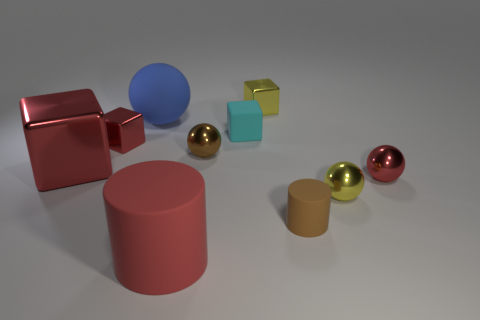Subtract all tiny yellow spheres. How many spheres are left? 3 Subtract all gray cubes. Subtract all gray spheres. How many cubes are left? 4 Subtract all cylinders. How many objects are left? 8 Add 9 large red rubber objects. How many large red rubber objects are left? 10 Add 2 small metallic cubes. How many small metallic cubes exist? 4 Subtract 0 brown cubes. How many objects are left? 10 Subtract all big red metal objects. Subtract all yellow balls. How many objects are left? 8 